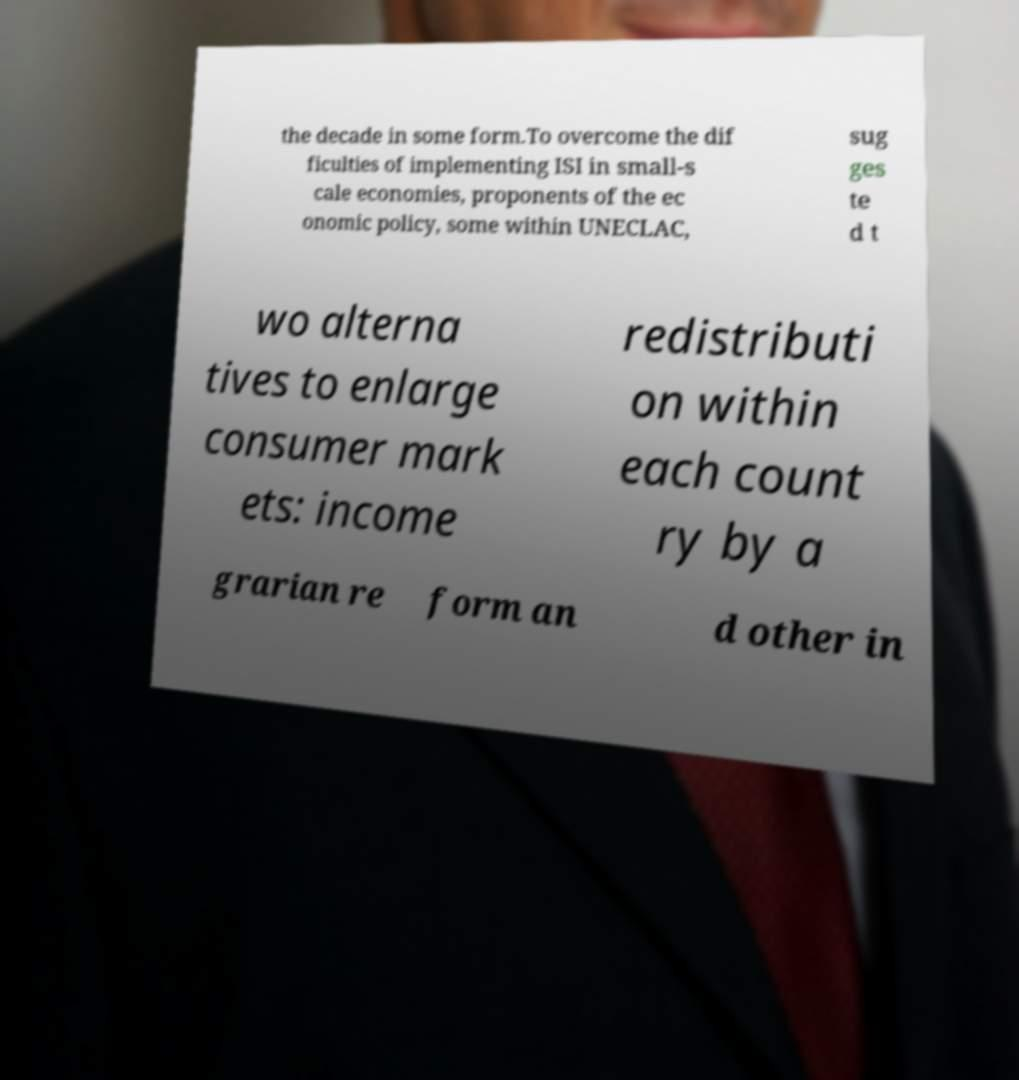Please identify and transcribe the text found in this image. the decade in some form.To overcome the dif ficulties of implementing ISI in small-s cale economies, proponents of the ec onomic policy, some within UNECLAC, sug ges te d t wo alterna tives to enlarge consumer mark ets: income redistributi on within each count ry by a grarian re form an d other in 